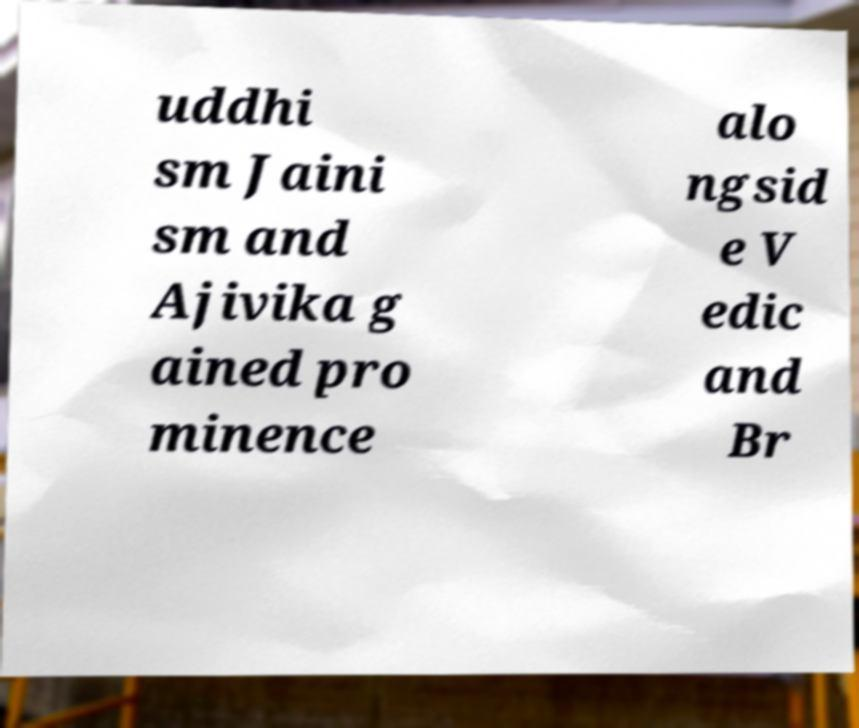Can you read and provide the text displayed in the image?This photo seems to have some interesting text. Can you extract and type it out for me? uddhi sm Jaini sm and Ajivika g ained pro minence alo ngsid e V edic and Br 